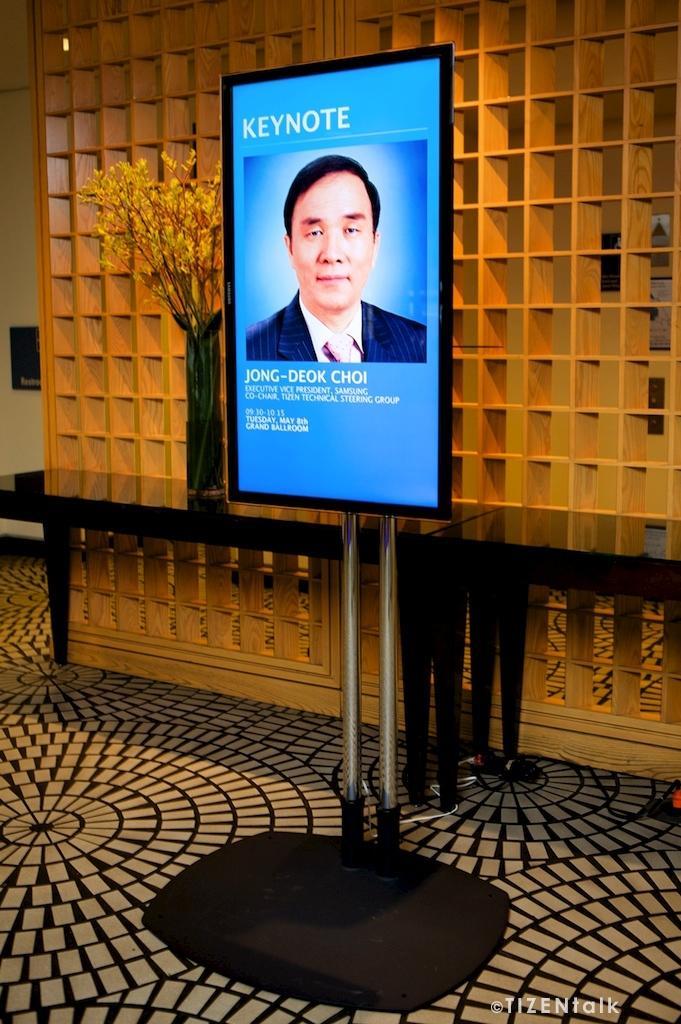Describe this image in one or two sentences. In this image we can see a screen on a stand. On the screen we can see a photo of a person and text. In the back there is a wall. Also there are tables. On the table there is a flower vase. In the flower case there are stems with flowers. 